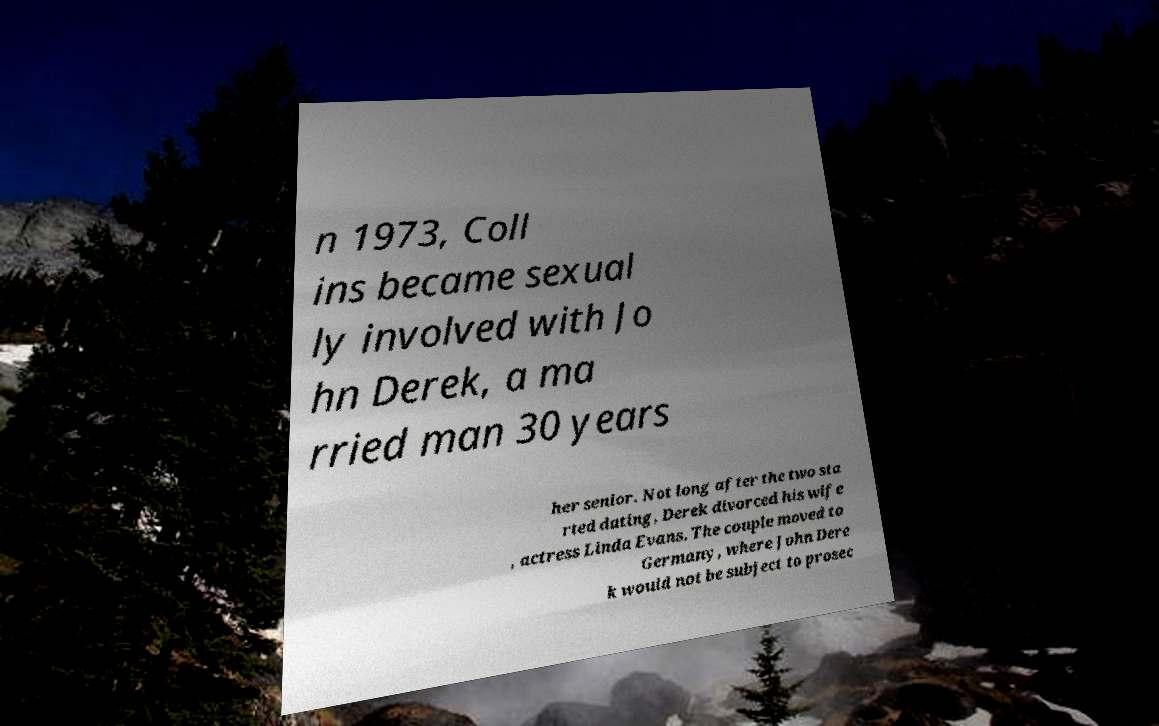Can you accurately transcribe the text from the provided image for me? n 1973, Coll ins became sexual ly involved with Jo hn Derek, a ma rried man 30 years her senior. Not long after the two sta rted dating, Derek divorced his wife , actress Linda Evans. The couple moved to Germany, where John Dere k would not be subject to prosec 